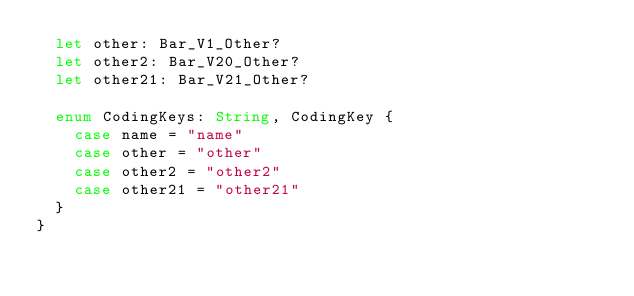Convert code to text. <code><loc_0><loc_0><loc_500><loc_500><_Swift_>  let other: Bar_V1_Other?
  let other2: Bar_V20_Other?
  let other21: Bar_V21_Other?

  enum CodingKeys: String, CodingKey {
    case name = "name"
    case other = "other"
    case other2 = "other2"
    case other21 = "other21"
  }
}
</code> 